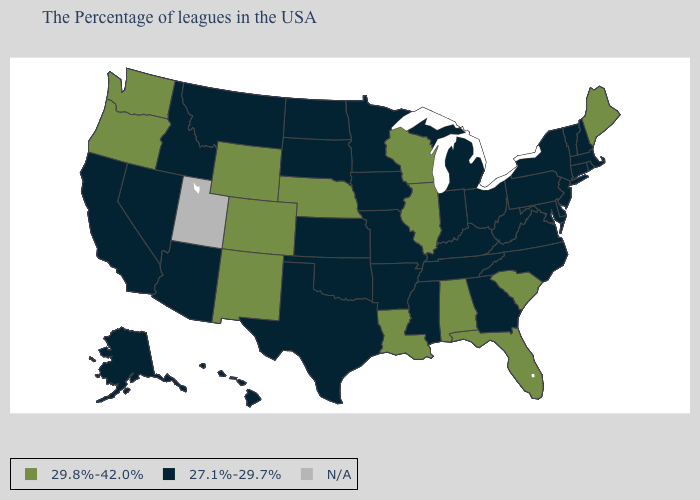What is the value of Kansas?
Keep it brief. 27.1%-29.7%. What is the value of Montana?
Quick response, please. 27.1%-29.7%. What is the highest value in the USA?
Be succinct. 29.8%-42.0%. What is the lowest value in the USA?
Short answer required. 27.1%-29.7%. What is the value of Colorado?
Be succinct. 29.8%-42.0%. Name the states that have a value in the range 27.1%-29.7%?
Concise answer only. Massachusetts, Rhode Island, New Hampshire, Vermont, Connecticut, New York, New Jersey, Delaware, Maryland, Pennsylvania, Virginia, North Carolina, West Virginia, Ohio, Georgia, Michigan, Kentucky, Indiana, Tennessee, Mississippi, Missouri, Arkansas, Minnesota, Iowa, Kansas, Oklahoma, Texas, South Dakota, North Dakota, Montana, Arizona, Idaho, Nevada, California, Alaska, Hawaii. Name the states that have a value in the range 27.1%-29.7%?
Answer briefly. Massachusetts, Rhode Island, New Hampshire, Vermont, Connecticut, New York, New Jersey, Delaware, Maryland, Pennsylvania, Virginia, North Carolina, West Virginia, Ohio, Georgia, Michigan, Kentucky, Indiana, Tennessee, Mississippi, Missouri, Arkansas, Minnesota, Iowa, Kansas, Oklahoma, Texas, South Dakota, North Dakota, Montana, Arizona, Idaho, Nevada, California, Alaska, Hawaii. Among the states that border Florida , which have the lowest value?
Quick response, please. Georgia. Is the legend a continuous bar?
Concise answer only. No. Name the states that have a value in the range 29.8%-42.0%?
Short answer required. Maine, South Carolina, Florida, Alabama, Wisconsin, Illinois, Louisiana, Nebraska, Wyoming, Colorado, New Mexico, Washington, Oregon. Does Georgia have the lowest value in the South?
Concise answer only. Yes. Name the states that have a value in the range 27.1%-29.7%?
Short answer required. Massachusetts, Rhode Island, New Hampshire, Vermont, Connecticut, New York, New Jersey, Delaware, Maryland, Pennsylvania, Virginia, North Carolina, West Virginia, Ohio, Georgia, Michigan, Kentucky, Indiana, Tennessee, Mississippi, Missouri, Arkansas, Minnesota, Iowa, Kansas, Oklahoma, Texas, South Dakota, North Dakota, Montana, Arizona, Idaho, Nevada, California, Alaska, Hawaii. Among the states that border Oklahoma , which have the lowest value?
Write a very short answer. Missouri, Arkansas, Kansas, Texas. Name the states that have a value in the range 27.1%-29.7%?
Answer briefly. Massachusetts, Rhode Island, New Hampshire, Vermont, Connecticut, New York, New Jersey, Delaware, Maryland, Pennsylvania, Virginia, North Carolina, West Virginia, Ohio, Georgia, Michigan, Kentucky, Indiana, Tennessee, Mississippi, Missouri, Arkansas, Minnesota, Iowa, Kansas, Oklahoma, Texas, South Dakota, North Dakota, Montana, Arizona, Idaho, Nevada, California, Alaska, Hawaii. What is the highest value in the USA?
Concise answer only. 29.8%-42.0%. 